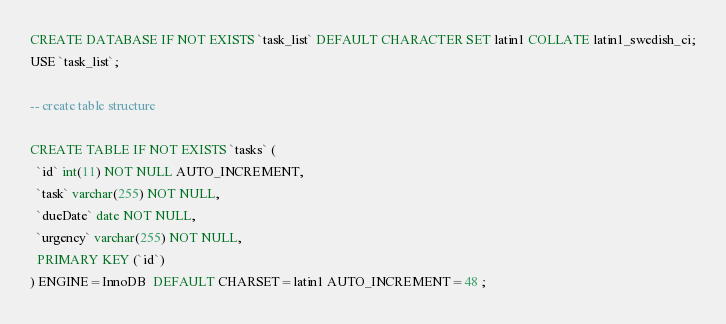Convert code to text. <code><loc_0><loc_0><loc_500><loc_500><_SQL_>CREATE DATABASE IF NOT EXISTS `task_list` DEFAULT CHARACTER SET latin1 COLLATE latin1_swedish_ci;
USE `task_list`;

-- create table structure

CREATE TABLE IF NOT EXISTS `tasks` (
  `id` int(11) NOT NULL AUTO_INCREMENT,
  `task` varchar(255) NOT NULL,
  `dueDate` date NOT NULL,
  `urgency` varchar(255) NOT NULL,
  PRIMARY KEY (`id`)
) ENGINE=InnoDB  DEFAULT CHARSET=latin1 AUTO_INCREMENT=48 ;
</code> 